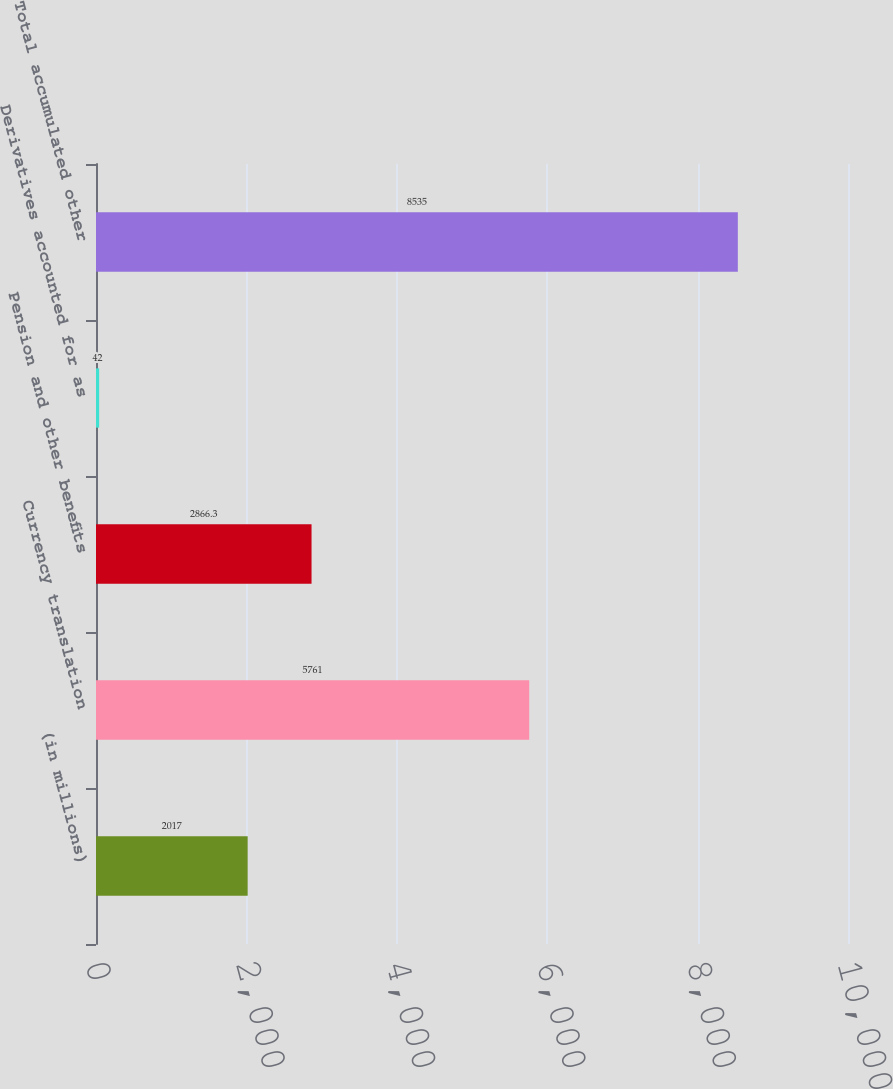Convert chart to OTSL. <chart><loc_0><loc_0><loc_500><loc_500><bar_chart><fcel>(in millions)<fcel>Currency translation<fcel>Pension and other benefits<fcel>Derivatives accounted for as<fcel>Total accumulated other<nl><fcel>2017<fcel>5761<fcel>2866.3<fcel>42<fcel>8535<nl></chart> 